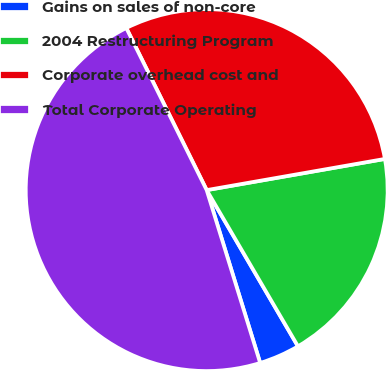Convert chart to OTSL. <chart><loc_0><loc_0><loc_500><loc_500><pie_chart><fcel>Gains on sales of non-core<fcel>2004 Restructuring Program<fcel>Corporate overhead cost and<fcel>Total Corporate Operating<nl><fcel>3.64%<fcel>19.34%<fcel>29.57%<fcel>47.45%<nl></chart> 